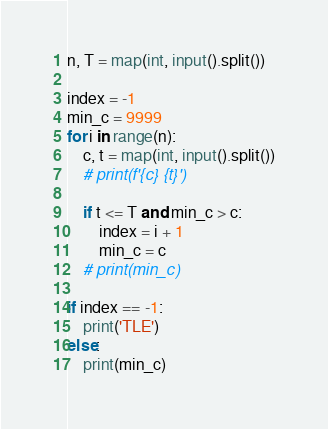Convert code to text. <code><loc_0><loc_0><loc_500><loc_500><_Python_>n, T = map(int, input().split())

index = -1
min_c = 9999
for i in range(n):
    c, t = map(int, input().split())
    # print(f'{c} {t}')
    
    if t <= T and min_c > c:
        index = i + 1
        min_c = c
    # print(min_c)
        
if index == -1:
    print('TLE')
else:
    print(min_c)</code> 